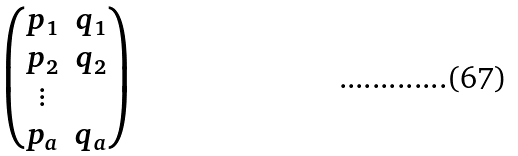<formula> <loc_0><loc_0><loc_500><loc_500>\begin{pmatrix} p _ { 1 } & q _ { 1 } \\ p _ { 2 } & q _ { 2 } \\ \vdots \\ p _ { a } & q _ { a } \end{pmatrix}</formula> 